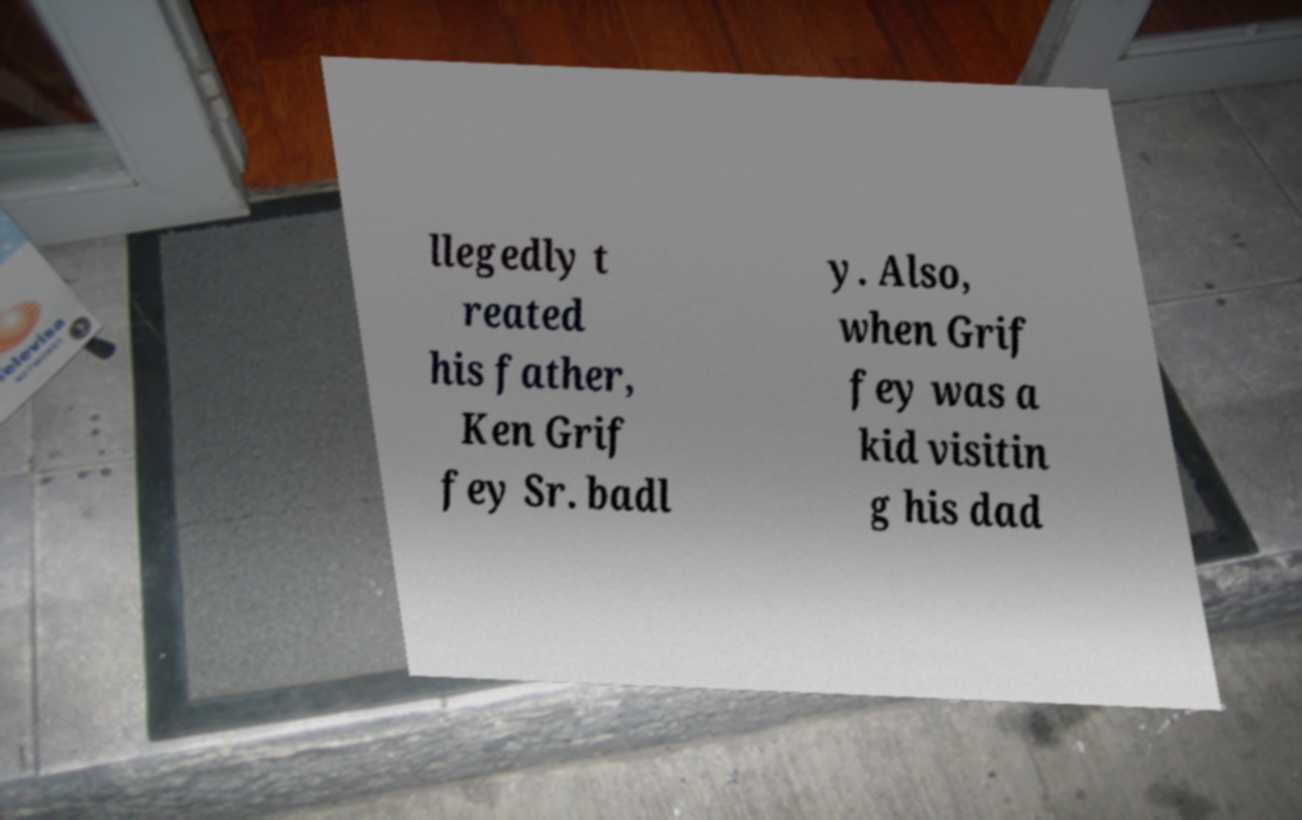For documentation purposes, I need the text within this image transcribed. Could you provide that? llegedly t reated his father, Ken Grif fey Sr. badl y. Also, when Grif fey was a kid visitin g his dad 